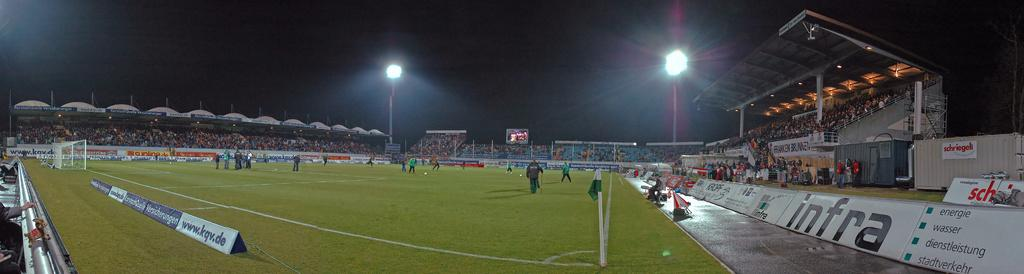<image>
Describe the image concisely. The ad on the one sign is for www.kqv.de 